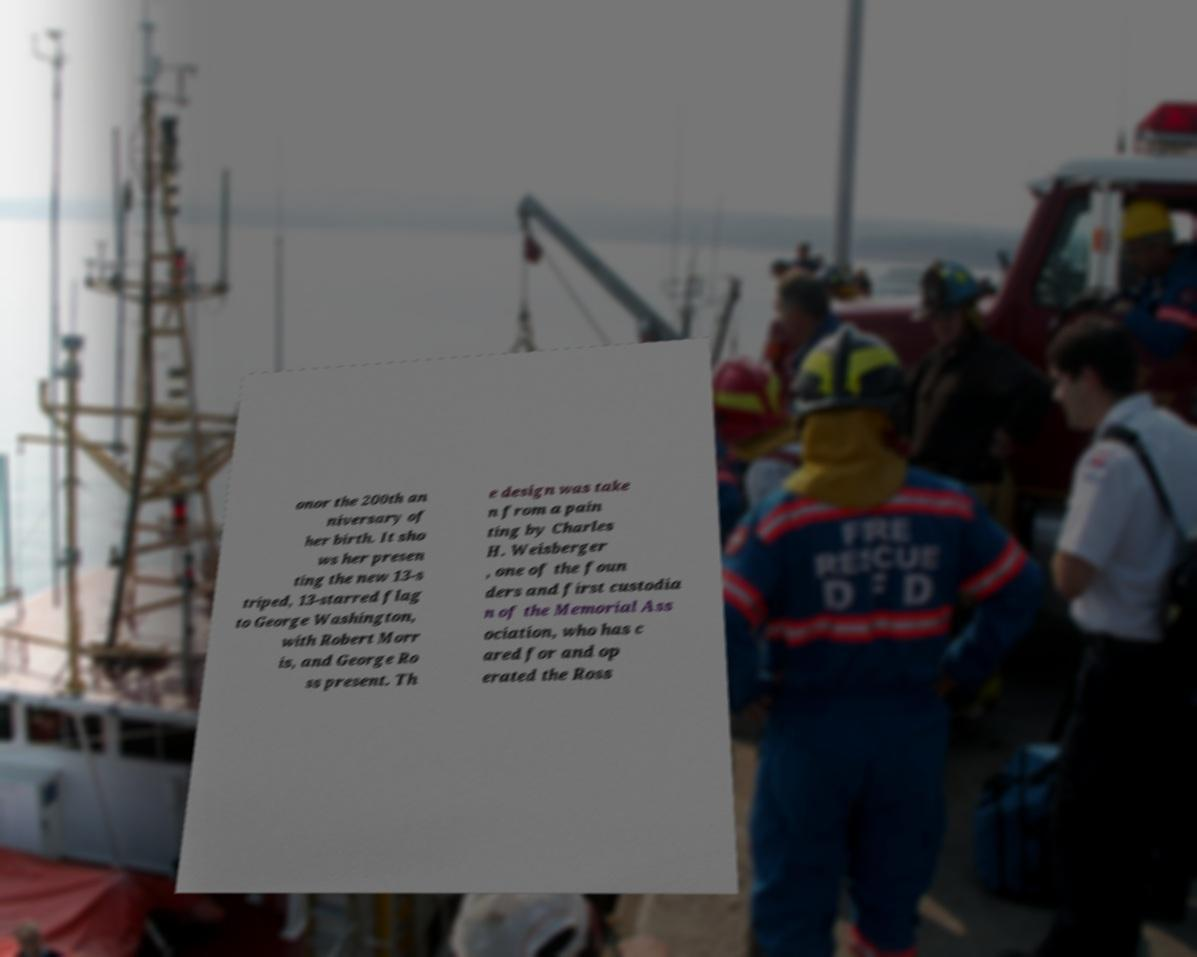Can you accurately transcribe the text from the provided image for me? onor the 200th an niversary of her birth. It sho ws her presen ting the new 13-s triped, 13-starred flag to George Washington, with Robert Morr is, and George Ro ss present. Th e design was take n from a pain ting by Charles H. Weisberger , one of the foun ders and first custodia n of the Memorial Ass ociation, who has c ared for and op erated the Ross 